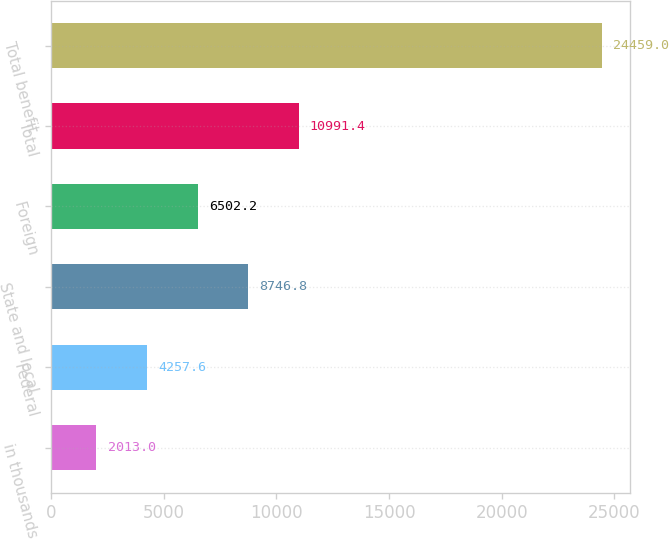Convert chart to OTSL. <chart><loc_0><loc_0><loc_500><loc_500><bar_chart><fcel>in thousands<fcel>Federal<fcel>State and local<fcel>Foreign<fcel>Total<fcel>Total benefit<nl><fcel>2013<fcel>4257.6<fcel>8746.8<fcel>6502.2<fcel>10991.4<fcel>24459<nl></chart> 